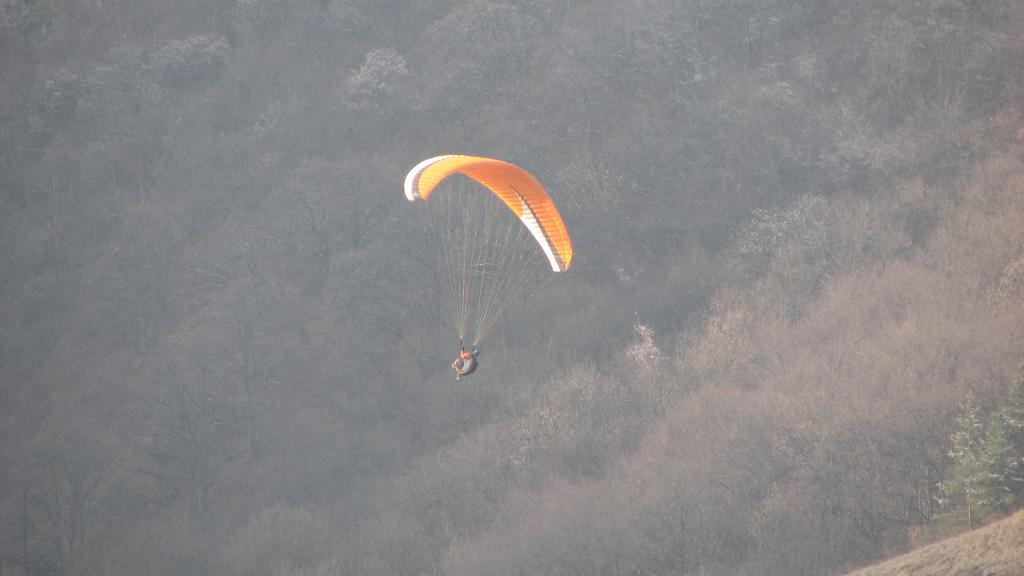What is the person in the image doing? There is a person with a parachute in the air in the image. What can be seen in the background of the image? There are many trees in the image. What type of vegetation is present in the image? There are plants in the image. What type of lamp can be seen in the image? There is no lamp present in the image. What is the maid doing in the image? There is no maid present in the image. 